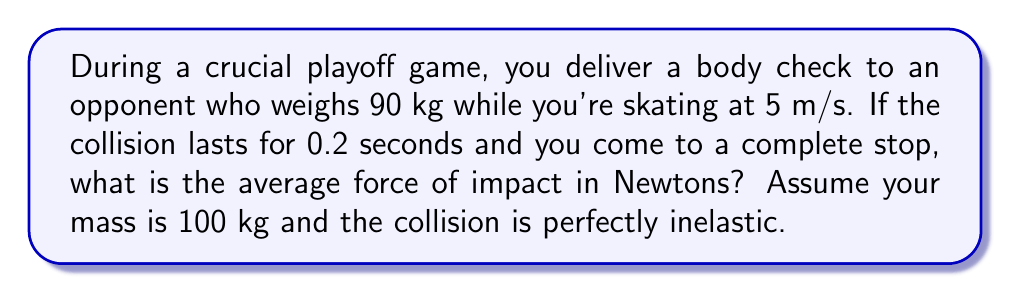Can you solve this math problem? Let's approach this step-by-step using the principles of impulse and momentum:

1) First, we need to calculate the change in momentum. In a perfectly inelastic collision, the two players will move together after impact.

2) Initial momentum:
   $p_i = m_1v_1 + m_2v_2 = 100 \text{ kg} \cdot 5 \text{ m/s} + 90 \text{ kg} \cdot 0 \text{ m/s} = 500 \text{ kg}\cdot\text{m/s}$

3) Final momentum:
   $p_f = (m_1 + m_2)v_f$
   We don't know $v_f$, but we know the total mass is now moving together.

4) Change in momentum:
   $\Delta p = p_f - p_i = (m_1 + m_2)v_f - 500 \text{ kg}\cdot\text{m/s}$

5) Now, we can use the impulse-momentum theorem:
   $F\Delta t = \Delta p$

6) Rearranging for force:
   $F = \frac{\Delta p}{\Delta t} = \frac{(m_1 + m_2)v_f - 500 \text{ kg}\cdot\text{m/s}}{0.2 \text{ s}}$

7) To find $v_f$, we can use conservation of momentum:
   $500 \text{ kg}\cdot\text{m/s} = (100 \text{ kg} + 90 \text{ kg})v_f$
   $v_f = \frac{500 \text{ kg}\cdot\text{m/s}}{190 \text{ kg}} \approx 2.63 \text{ m/s}$

8) Now we can calculate the force:
   $F = \frac{(190 \text{ kg} \cdot 2.63 \text{ m/s}) - 500 \text{ kg}\cdot\text{m/s}}{0.2 \text{ s}}$
   $F = \frac{-0.3 \text{ kg}\cdot\text{m/s}}{0.2 \text{ s}} = -1.5 \text{ N}$

9) The negative sign indicates the force is in the opposite direction of the initial motion. The magnitude of the force is what we're interested in.

Therefore, the average force of impact is 1.5 N.
Answer: 1.5 N 